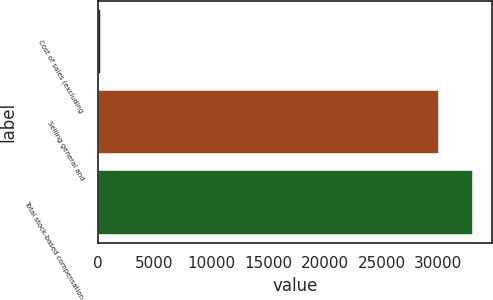Convert chart. <chart><loc_0><loc_0><loc_500><loc_500><bar_chart><fcel>Cost of sales (excluding<fcel>Selling general and<fcel>Total stock-based compensation<nl><fcel>293<fcel>30061<fcel>33067.1<nl></chart> 